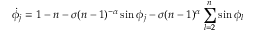Convert formula to latex. <formula><loc_0><loc_0><loc_500><loc_500>\dot { \phi _ { j } } = 1 - n - \sigma ( n - 1 ) ^ { - \alpha } \sin { \phi _ { j } } - \sigma ( n - 1 ) ^ { \alpha } \sum _ { l = 2 } ^ { n } \sin { \phi _ { l } }</formula> 